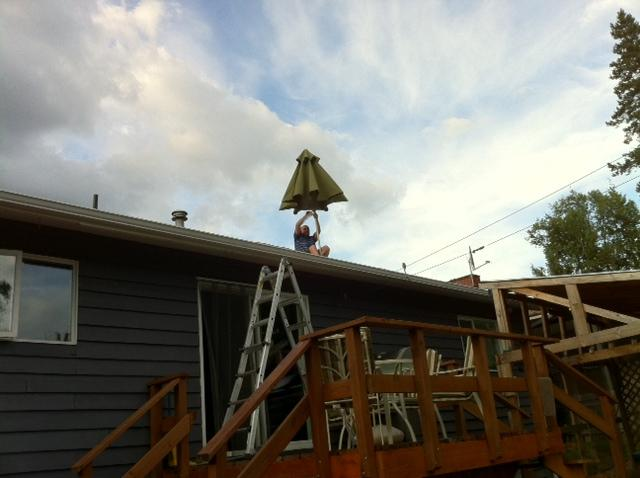What does the item the man is holding provide?

Choices:
A) fruit
B) shade
C) water
D) milk shade 